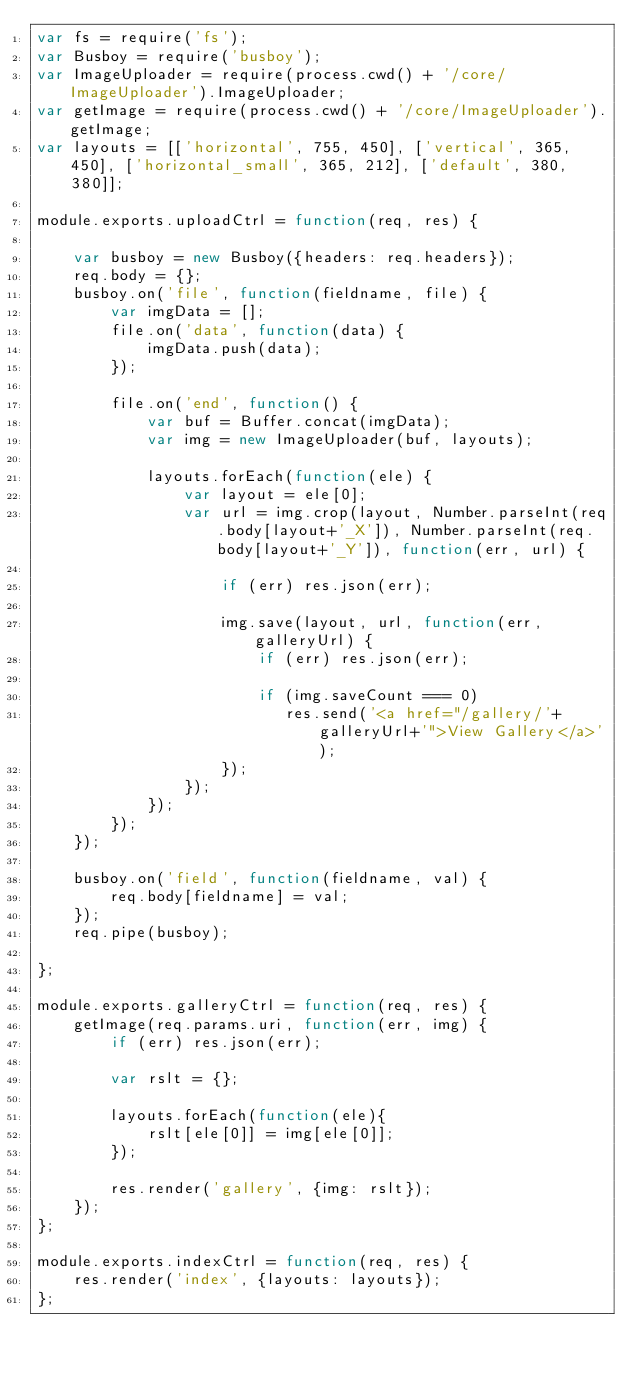<code> <loc_0><loc_0><loc_500><loc_500><_JavaScript_>var fs = require('fs');
var Busboy = require('busboy');
var ImageUploader = require(process.cwd() + '/core/ImageUploader').ImageUploader;
var getImage = require(process.cwd() + '/core/ImageUploader').getImage;
var layouts = [['horizontal', 755, 450], ['vertical', 365, 450], ['horizontal_small', 365, 212], ['default', 380, 380]];

module.exports.uploadCtrl = function(req, res) {

    var busboy = new Busboy({headers: req.headers});
    req.body = {};
    busboy.on('file', function(fieldname, file) {
        var imgData = [];
        file.on('data', function(data) {
            imgData.push(data);
        });

        file.on('end', function() {
            var buf = Buffer.concat(imgData);
            var img = new ImageUploader(buf, layouts);

            layouts.forEach(function(ele) {
                var layout = ele[0];
                var url = img.crop(layout, Number.parseInt(req.body[layout+'_X']), Number.parseInt(req.body[layout+'_Y']), function(err, url) {
                    
                    if (err) res.json(err);

                    img.save(layout, url, function(err, galleryUrl) {
                        if (err) res.json(err);

                        if (img.saveCount === 0)
                           res.send('<a href="/gallery/'+galleryUrl+'">View Gallery</a>');
                    });
                });
            });
        });
    });

    busboy.on('field', function(fieldname, val) {
        req.body[fieldname] = val;
    });
    req.pipe(busboy);

};

module.exports.galleryCtrl = function(req, res) {
    getImage(req.params.uri, function(err, img) {
        if (err) res.json(err);

        var rslt = {};
        
        layouts.forEach(function(ele){
            rslt[ele[0]] = img[ele[0]];
        });

        res.render('gallery', {img: rslt});
    });
};

module.exports.indexCtrl = function(req, res) {
    res.render('index', {layouts: layouts});
};</code> 